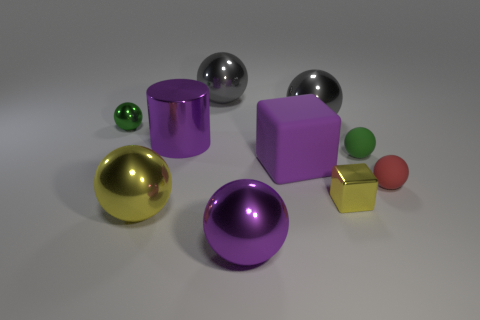What number of objects are either shiny objects that are on the left side of the big yellow ball or small cyan rubber cylinders?
Your answer should be very brief. 1. How many purple cylinders are behind the tiny metal object that is behind the large metallic cylinder?
Make the answer very short. 0. Is the number of green spheres that are in front of the red sphere less than the number of metal spheres on the left side of the large matte object?
Give a very brief answer. Yes. There is a yellow shiny object that is left of the large purple shiny object left of the big purple metal sphere; what shape is it?
Your answer should be very brief. Sphere. What number of other objects are there of the same material as the small red object?
Provide a succinct answer. 2. Is the number of tiny metallic cylinders greater than the number of big shiny cylinders?
Your answer should be compact. No. What size is the green ball behind the green ball that is right of the big purple shiny object in front of the red ball?
Make the answer very short. Small. There is a green rubber thing; is its size the same as the green object behind the tiny green matte ball?
Your answer should be compact. Yes. Are there fewer green metal balls in front of the rubber cube than tiny metallic things?
Your answer should be very brief. Yes. How many large matte objects have the same color as the cylinder?
Your answer should be very brief. 1. 